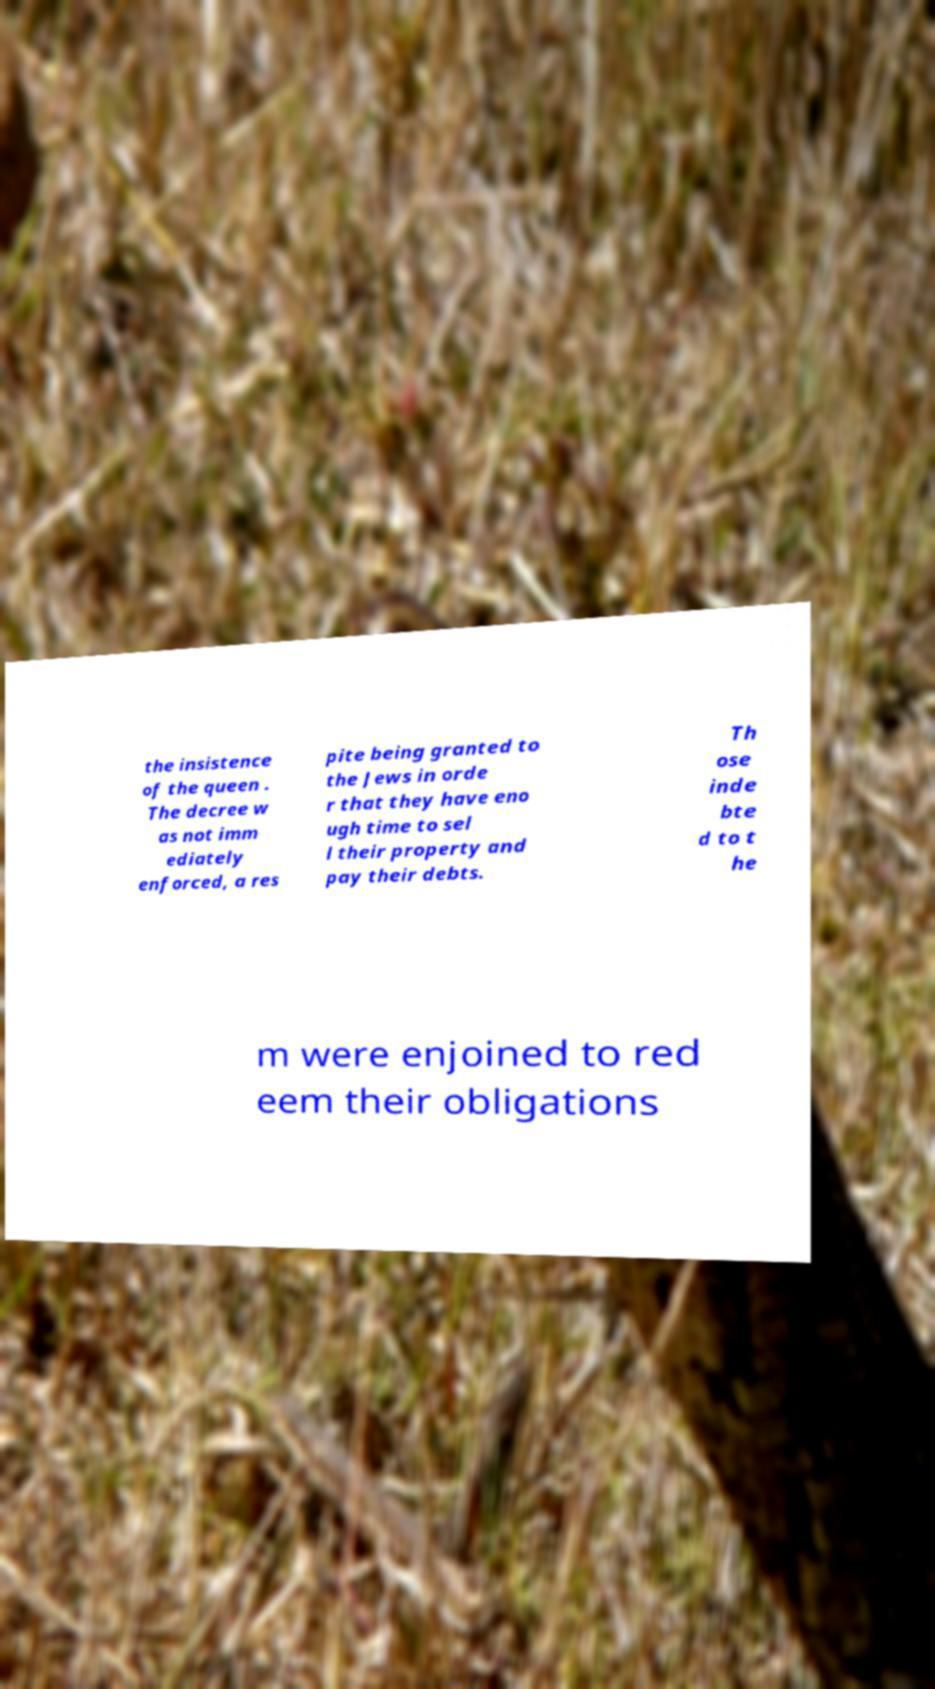For documentation purposes, I need the text within this image transcribed. Could you provide that? the insistence of the queen . The decree w as not imm ediately enforced, a res pite being granted to the Jews in orde r that they have eno ugh time to sel l their property and pay their debts. Th ose inde bte d to t he m were enjoined to red eem their obligations 